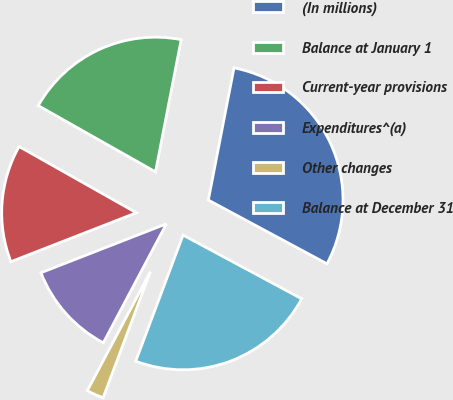Convert chart to OTSL. <chart><loc_0><loc_0><loc_500><loc_500><pie_chart><fcel>(In millions)<fcel>Balance at January 1<fcel>Current-year provisions<fcel>Expenditures^(a)<fcel>Other changes<fcel>Balance at December 31<nl><fcel>29.79%<fcel>19.87%<fcel>14.1%<fcel>11.32%<fcel>2.05%<fcel>22.87%<nl></chart> 